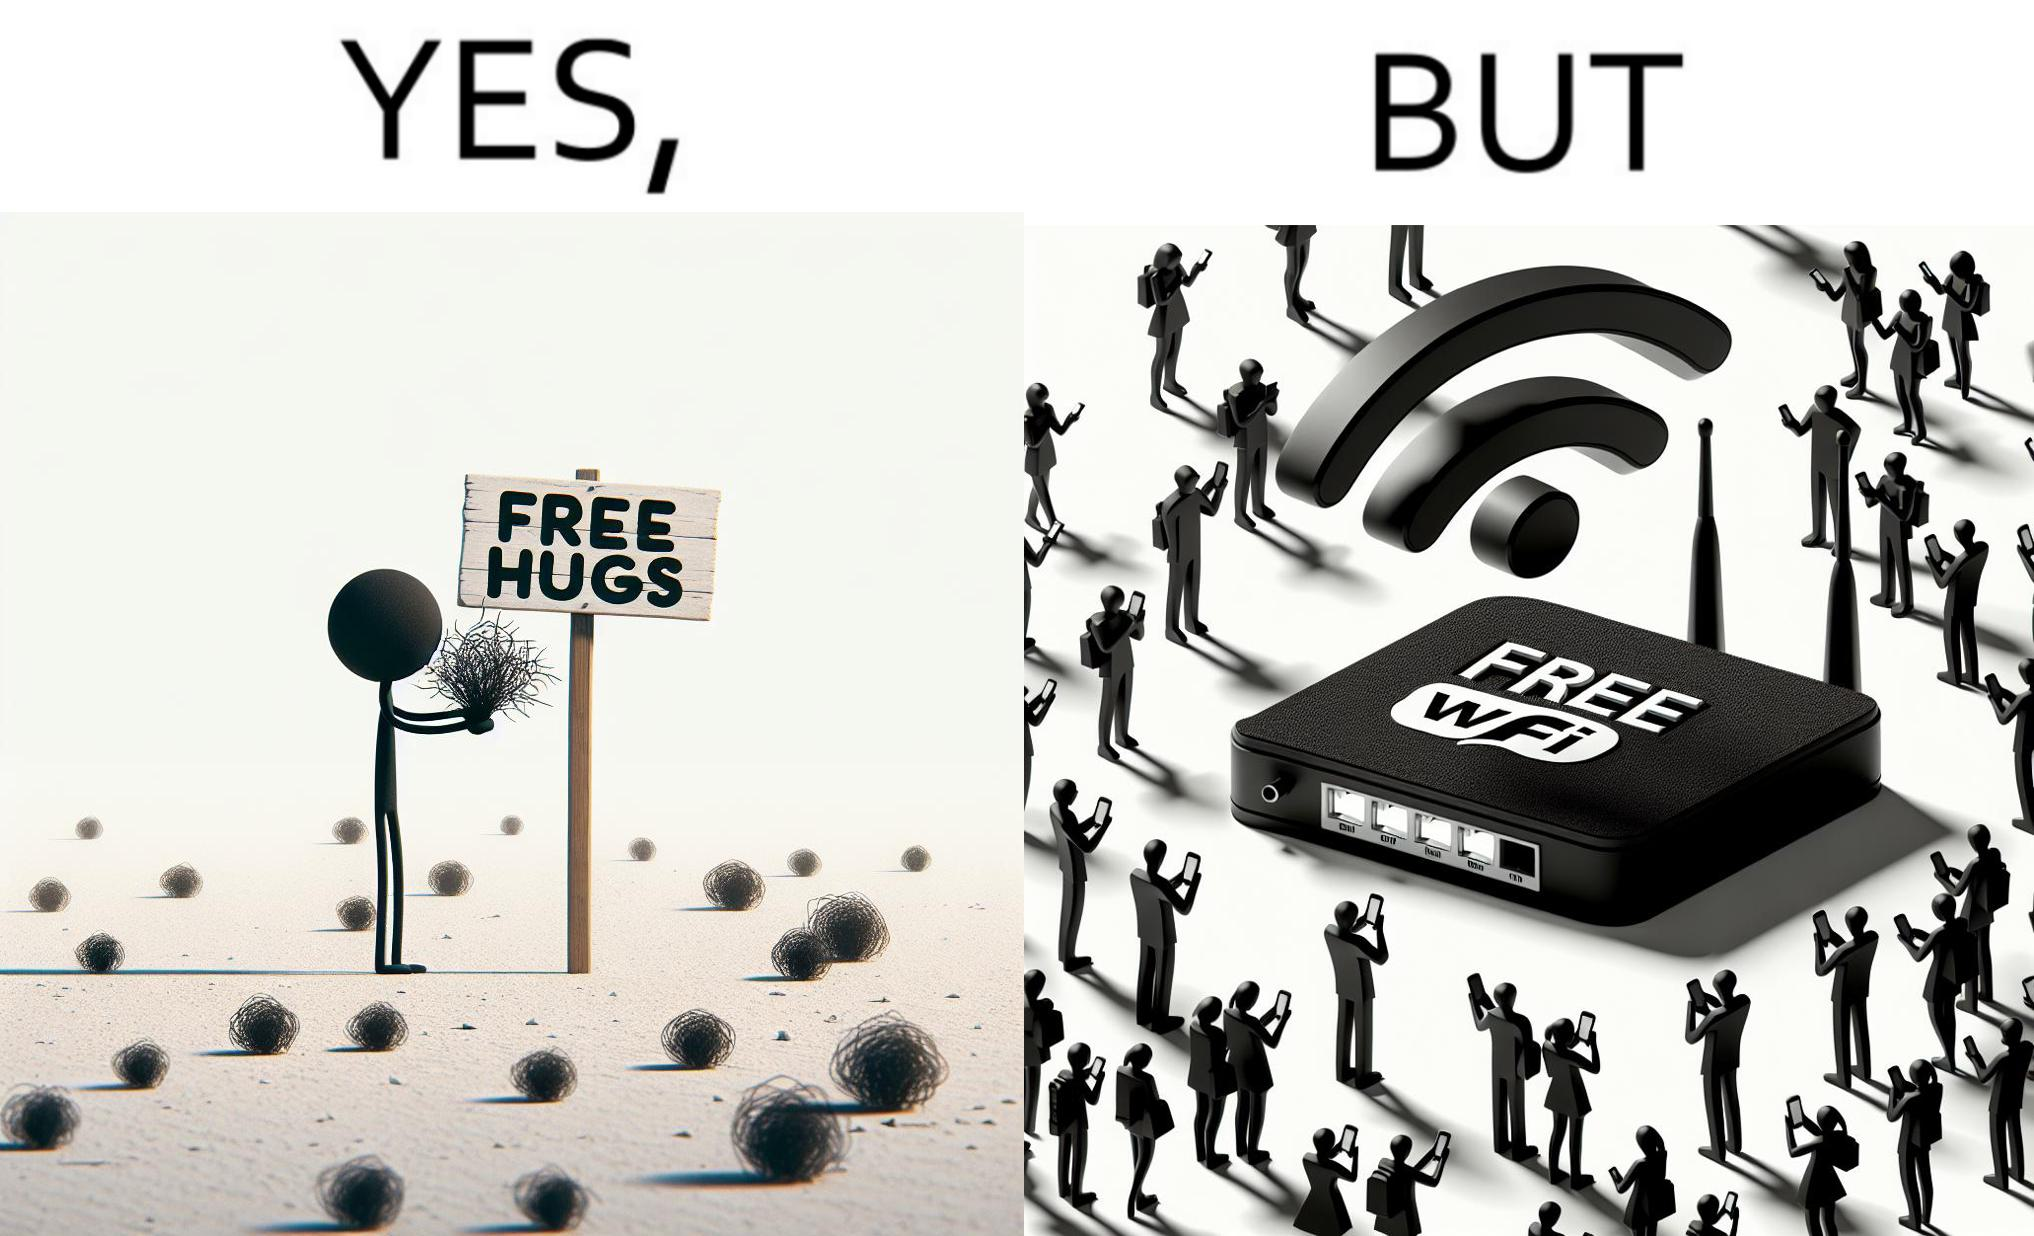Would you classify this image as satirical? Yes, this image is satirical. 